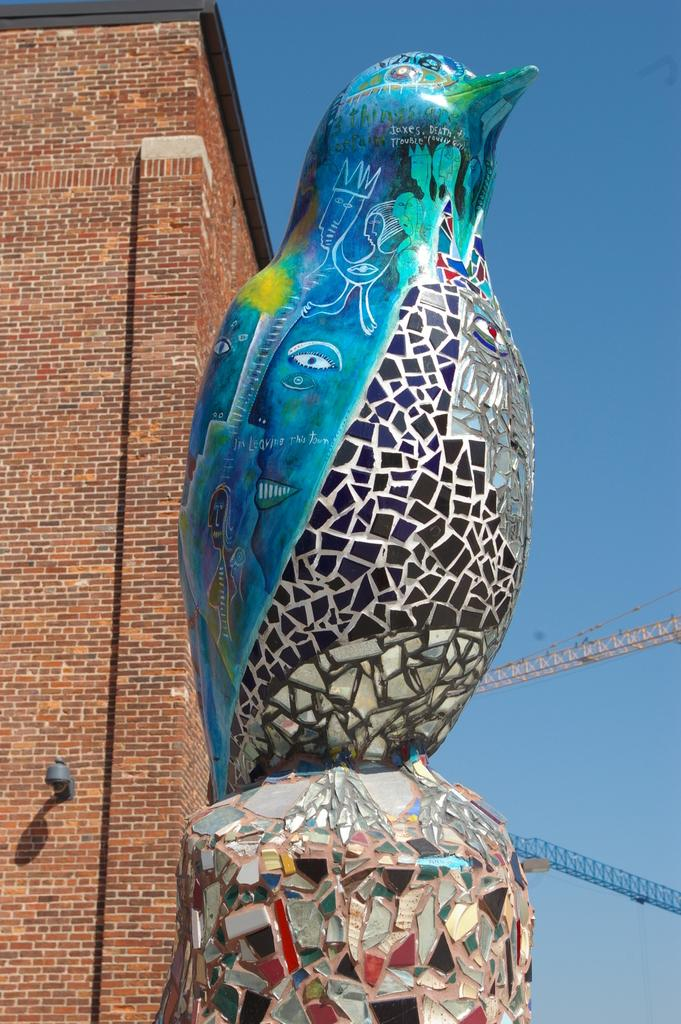What is the main subject of the image? There is a statue of a bird in the image. What can be seen in the background of the image? There is a building and the sky visible in the background of the image. Are there any other objects present in the background? Yes, there are other objects present in the background of the image. What type of needle is being used by the bird in the image? There is no needle present in the image, as it features a statue of a bird and not a living bird. 